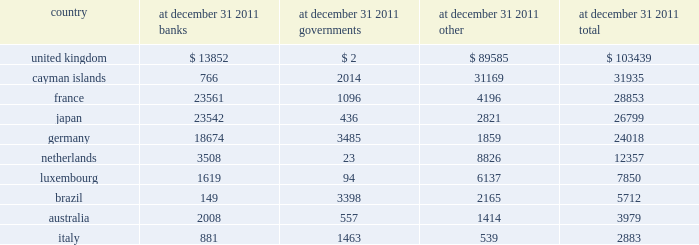Financial data supplement ( unaudited ) 2014 ( continued ) .

Are the japan banks larger than the german government? 
Computations: (23542 > 3485)
Answer: yes. 